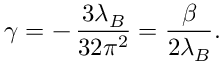Convert formula to latex. <formula><loc_0><loc_0><loc_500><loc_500>\gamma = - \, { \frac { 3 \lambda _ { B } } { 3 2 \pi ^ { 2 } } } = { \frac { \beta } { 2 \lambda _ { B } } } .</formula> 